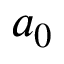Convert formula to latex. <formula><loc_0><loc_0><loc_500><loc_500>a _ { 0 }</formula> 